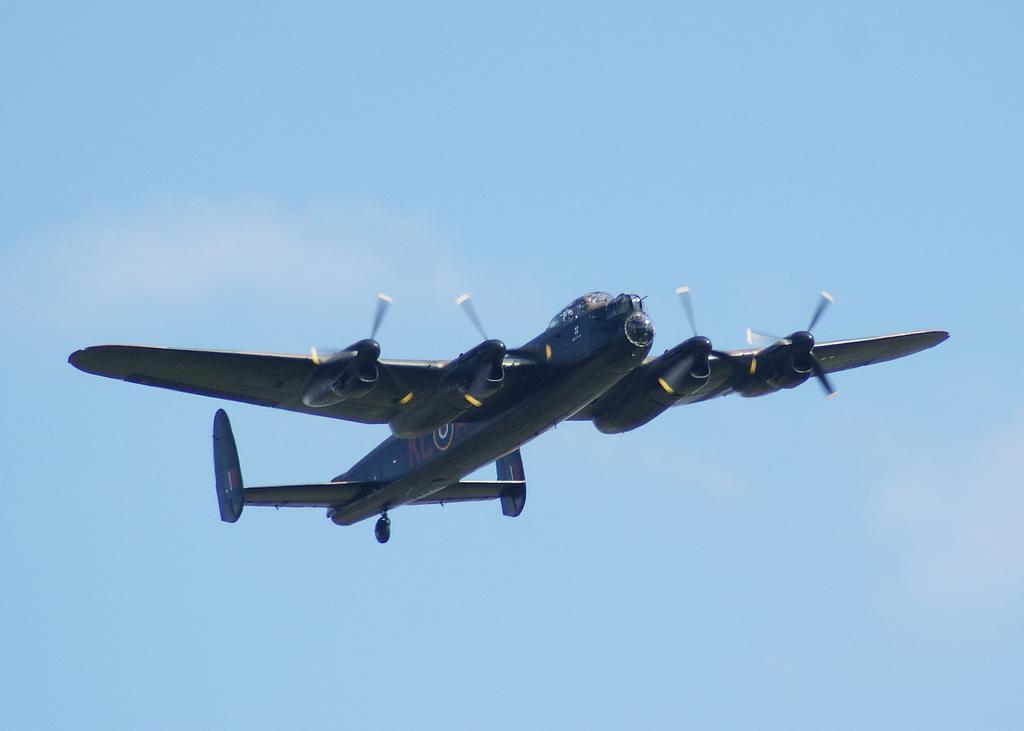Describe this image in one or two sentences. In this image an airplane flying in the sky. 